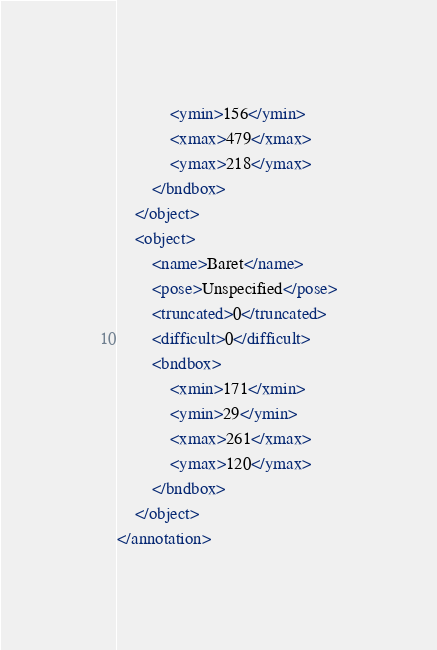<code> <loc_0><loc_0><loc_500><loc_500><_XML_>			<ymin>156</ymin>
			<xmax>479</xmax>
			<ymax>218</ymax>
		</bndbox>
	</object>
	<object>
		<name>Baret</name>
		<pose>Unspecified</pose>
		<truncated>0</truncated>
		<difficult>0</difficult>
		<bndbox>
			<xmin>171</xmin>
			<ymin>29</ymin>
			<xmax>261</xmax>
			<ymax>120</ymax>
		</bndbox>
	</object>
</annotation>
</code> 